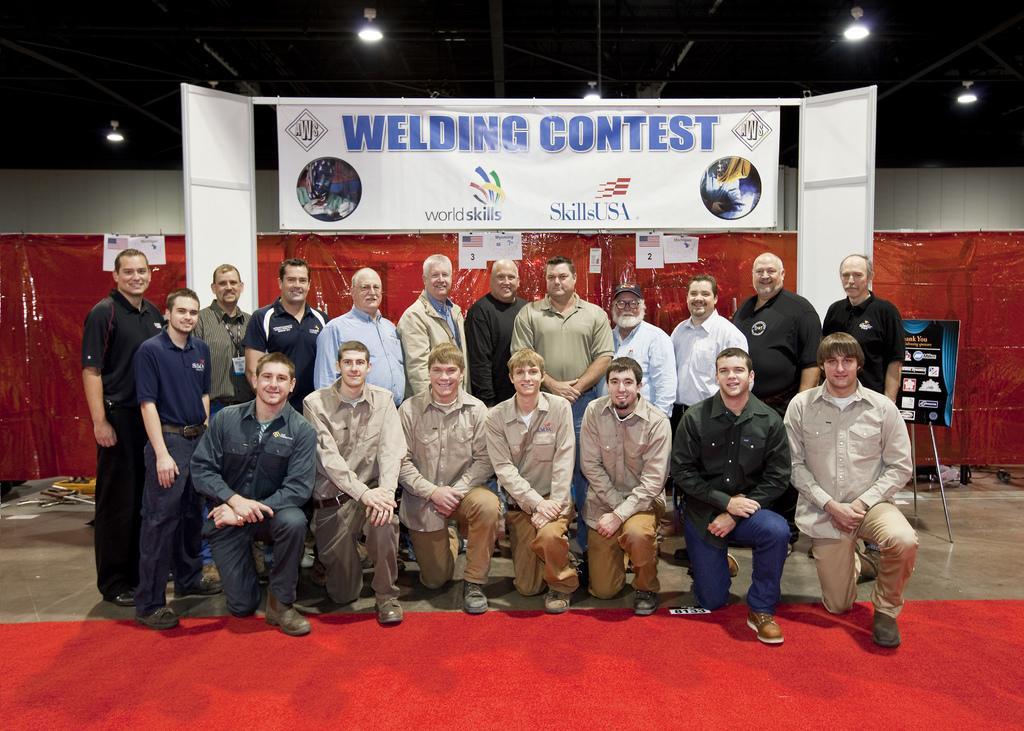In one or two sentences, can you explain what this image depicts? In this image we can see persons standing on the floor. In the background there are iron grills, electric lights, advertisement boards and a carpet. 